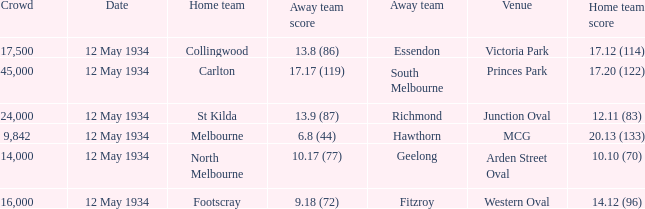What was the home teams score while playing the away team of south melbourne? 17.20 (122). 